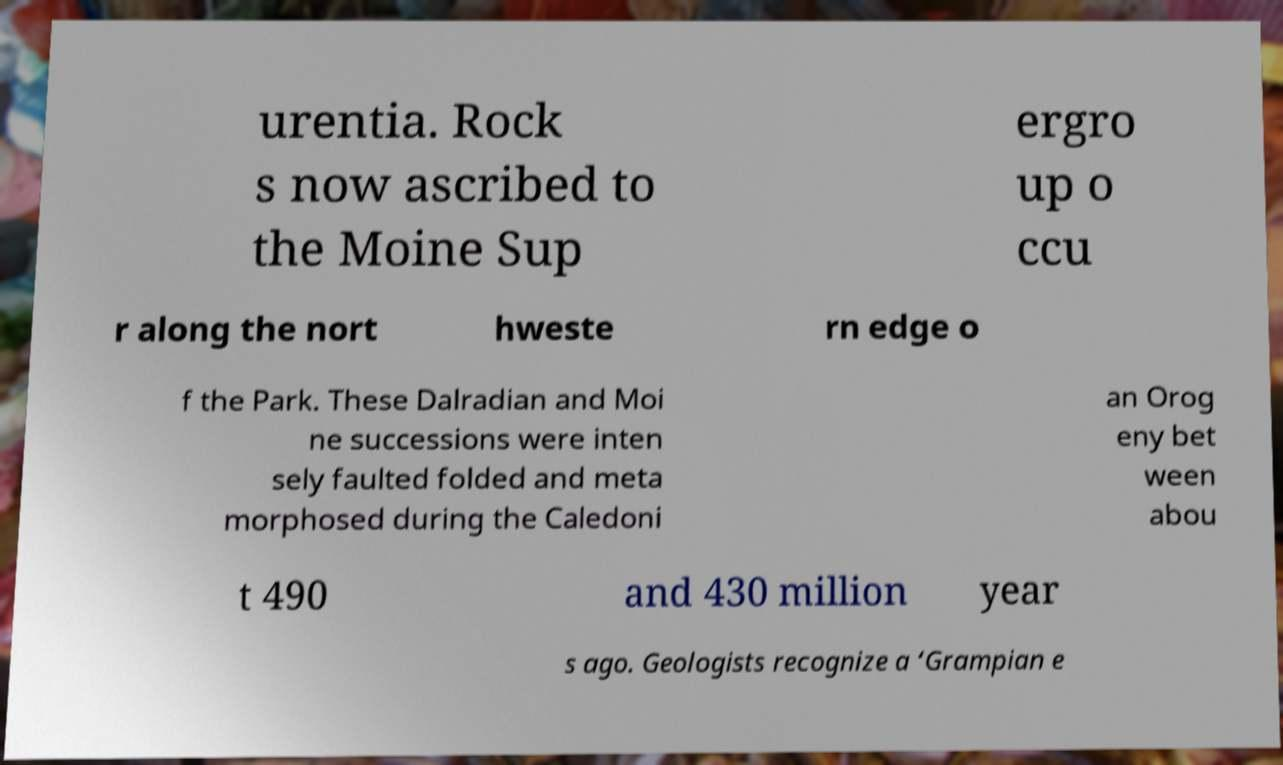Could you extract and type out the text from this image? urentia. Rock s now ascribed to the Moine Sup ergro up o ccu r along the nort hweste rn edge o f the Park. These Dalradian and Moi ne successions were inten sely faulted folded and meta morphosed during the Caledoni an Orog eny bet ween abou t 490 and 430 million year s ago. Geologists recognize a ‘Grampian e 